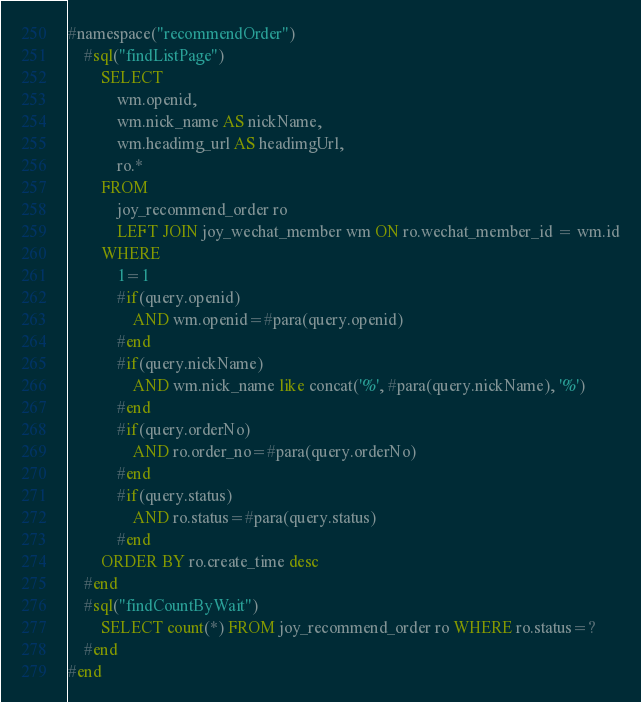Convert code to text. <code><loc_0><loc_0><loc_500><loc_500><_SQL_>#namespace("recommendOrder")
	#sql("findListPage")
		SELECT
			wm.openid,
			wm.nick_name AS nickName,
			wm.headimg_url AS headimgUrl,
			ro.* 
		FROM
			joy_recommend_order ro
			LEFT JOIN joy_wechat_member wm ON ro.wechat_member_id = wm.id
		WHERE
			1=1
			#if(query.openid)
				AND wm.openid=#para(query.openid)
			#end
			#if(query.nickName)
				AND wm.nick_name like concat('%', #para(query.nickName), '%')
			#end
			#if(query.orderNo)
				AND ro.order_no=#para(query.orderNo)
			#end
			#if(query.status)
				AND ro.status=#para(query.status)
			#end
		ORDER BY ro.create_time desc
	#end
	#sql("findCountByWait")
		SELECT count(*) FROM joy_recommend_order ro WHERE ro.status=?
	#end
#end</code> 